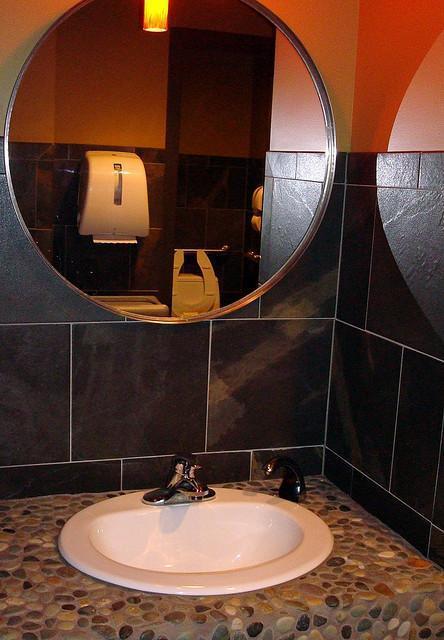How many people are in the picture?
Give a very brief answer. 0. 